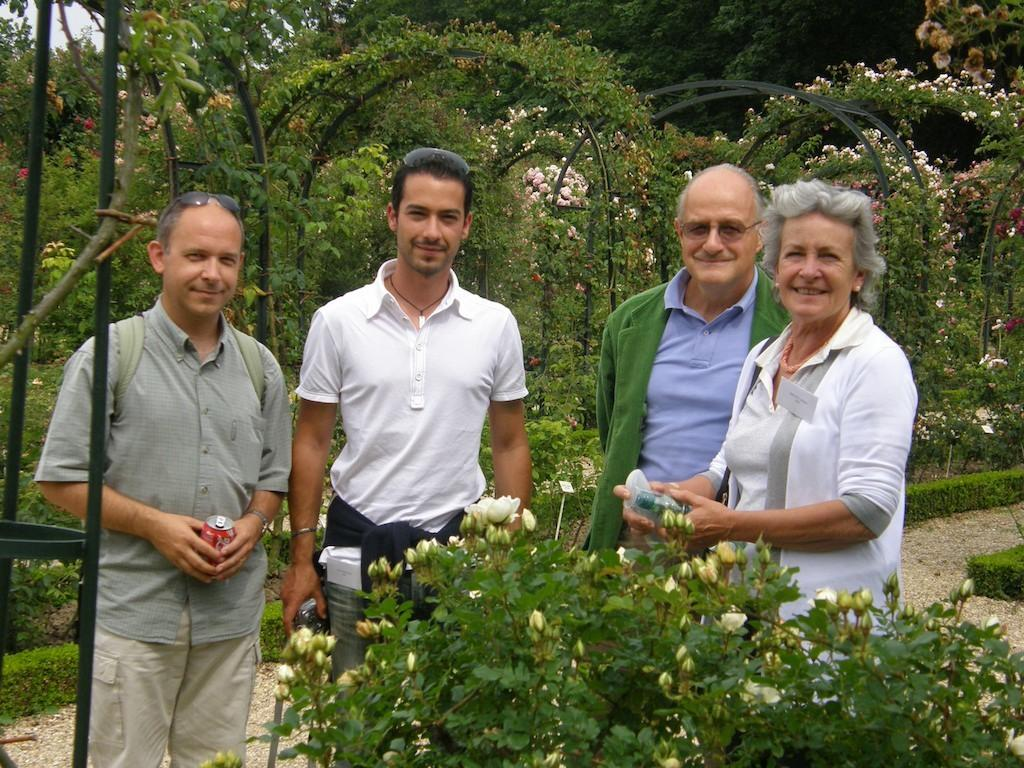What is happening in the image involving the group of people? The people in the image are smiling, which suggests they are enjoying themselves or engaged in a positive activity. What can be seen in the background of the image? There are trees and flowers in the background of the image. What type of hat is the secretary wearing in the image? There is no secretary or hat present in the image. What pen is the person using to write in the image? There is no person writing or pen present in the image. 